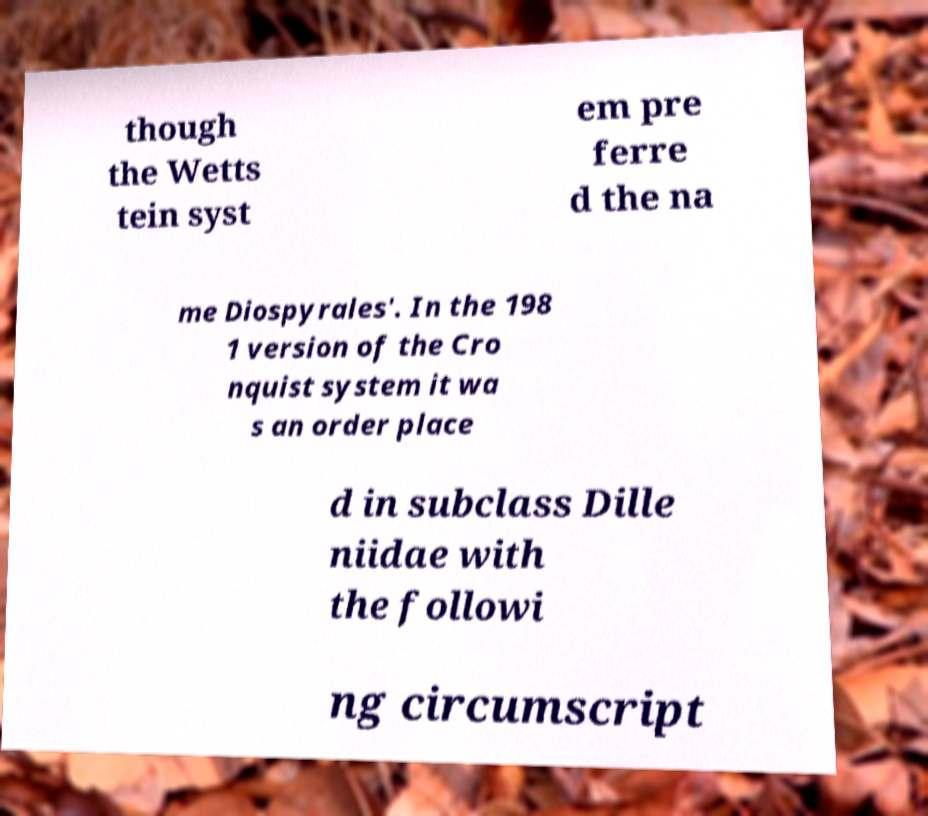Could you assist in decoding the text presented in this image and type it out clearly? though the Wetts tein syst em pre ferre d the na me Diospyrales'. In the 198 1 version of the Cro nquist system it wa s an order place d in subclass Dille niidae with the followi ng circumscript 